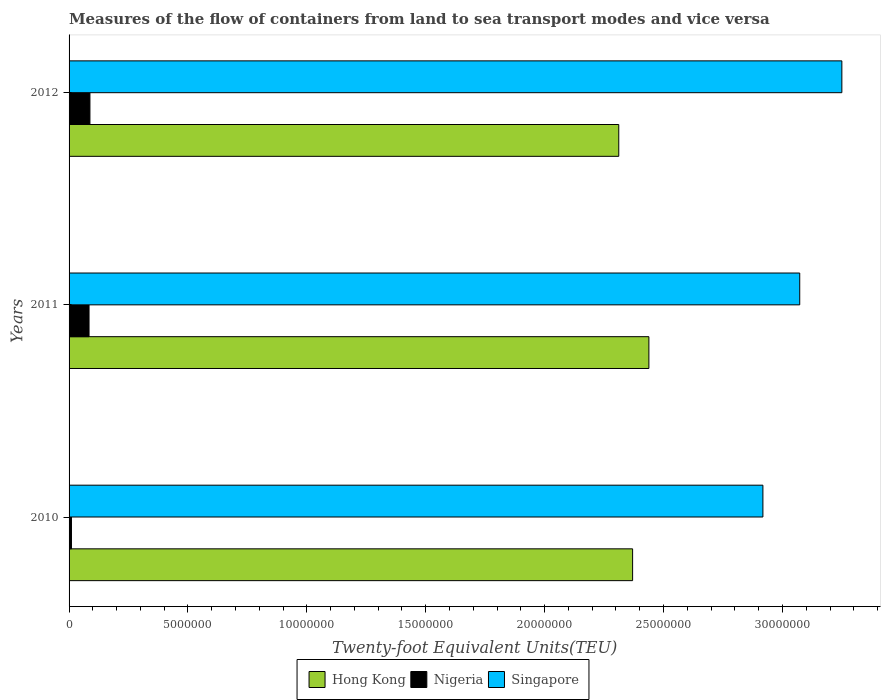How many different coloured bars are there?
Provide a succinct answer. 3. How many bars are there on the 1st tick from the top?
Provide a succinct answer. 3. How many bars are there on the 3rd tick from the bottom?
Offer a very short reply. 3. In how many cases, is the number of bars for a given year not equal to the number of legend labels?
Give a very brief answer. 0. What is the container port traffic in Nigeria in 2010?
Offer a terse response. 1.01e+05. Across all years, what is the maximum container port traffic in Hong Kong?
Keep it short and to the point. 2.44e+07. Across all years, what is the minimum container port traffic in Singapore?
Your answer should be compact. 2.92e+07. In which year was the container port traffic in Singapore maximum?
Give a very brief answer. 2012. What is the total container port traffic in Hong Kong in the graph?
Offer a terse response. 7.12e+07. What is the difference between the container port traffic in Nigeria in 2011 and that in 2012?
Give a very brief answer. -3.78e+04. What is the difference between the container port traffic in Hong Kong in 2011 and the container port traffic in Singapore in 2012?
Your response must be concise. -8.11e+06. What is the average container port traffic in Singapore per year?
Give a very brief answer. 3.08e+07. In the year 2012, what is the difference between the container port traffic in Nigeria and container port traffic in Singapore?
Your response must be concise. -3.16e+07. In how many years, is the container port traffic in Singapore greater than 18000000 TEU?
Give a very brief answer. 3. What is the ratio of the container port traffic in Hong Kong in 2010 to that in 2011?
Keep it short and to the point. 0.97. Is the difference between the container port traffic in Nigeria in 2010 and 2011 greater than the difference between the container port traffic in Singapore in 2010 and 2011?
Make the answer very short. Yes. What is the difference between the highest and the second highest container port traffic in Hong Kong?
Keep it short and to the point. 6.85e+05. What is the difference between the highest and the lowest container port traffic in Nigeria?
Your response must be concise. 7.77e+05. Is the sum of the container port traffic in Singapore in 2010 and 2012 greater than the maximum container port traffic in Hong Kong across all years?
Make the answer very short. Yes. What does the 1st bar from the top in 2011 represents?
Your answer should be very brief. Singapore. What does the 2nd bar from the bottom in 2010 represents?
Make the answer very short. Nigeria. Is it the case that in every year, the sum of the container port traffic in Hong Kong and container port traffic in Singapore is greater than the container port traffic in Nigeria?
Your response must be concise. Yes. What is the difference between two consecutive major ticks on the X-axis?
Keep it short and to the point. 5.00e+06. Are the values on the major ticks of X-axis written in scientific E-notation?
Keep it short and to the point. No. Does the graph contain any zero values?
Your answer should be very brief. No. Does the graph contain grids?
Ensure brevity in your answer.  No. Where does the legend appear in the graph?
Provide a succinct answer. Bottom center. What is the title of the graph?
Your answer should be compact. Measures of the flow of containers from land to sea transport modes and vice versa. What is the label or title of the X-axis?
Offer a terse response. Twenty-foot Equivalent Units(TEU). What is the label or title of the Y-axis?
Your response must be concise. Years. What is the Twenty-foot Equivalent Units(TEU) in Hong Kong in 2010?
Make the answer very short. 2.37e+07. What is the Twenty-foot Equivalent Units(TEU) in Nigeria in 2010?
Your answer should be compact. 1.01e+05. What is the Twenty-foot Equivalent Units(TEU) of Singapore in 2010?
Give a very brief answer. 2.92e+07. What is the Twenty-foot Equivalent Units(TEU) in Hong Kong in 2011?
Offer a very short reply. 2.44e+07. What is the Twenty-foot Equivalent Units(TEU) of Nigeria in 2011?
Your answer should be very brief. 8.40e+05. What is the Twenty-foot Equivalent Units(TEU) in Singapore in 2011?
Offer a terse response. 3.07e+07. What is the Twenty-foot Equivalent Units(TEU) of Hong Kong in 2012?
Keep it short and to the point. 2.31e+07. What is the Twenty-foot Equivalent Units(TEU) in Nigeria in 2012?
Offer a very short reply. 8.78e+05. What is the Twenty-foot Equivalent Units(TEU) of Singapore in 2012?
Make the answer very short. 3.25e+07. Across all years, what is the maximum Twenty-foot Equivalent Units(TEU) of Hong Kong?
Make the answer very short. 2.44e+07. Across all years, what is the maximum Twenty-foot Equivalent Units(TEU) of Nigeria?
Your answer should be compact. 8.78e+05. Across all years, what is the maximum Twenty-foot Equivalent Units(TEU) of Singapore?
Your answer should be very brief. 3.25e+07. Across all years, what is the minimum Twenty-foot Equivalent Units(TEU) of Hong Kong?
Make the answer very short. 2.31e+07. Across all years, what is the minimum Twenty-foot Equivalent Units(TEU) in Nigeria?
Ensure brevity in your answer.  1.01e+05. Across all years, what is the minimum Twenty-foot Equivalent Units(TEU) in Singapore?
Keep it short and to the point. 2.92e+07. What is the total Twenty-foot Equivalent Units(TEU) of Hong Kong in the graph?
Your response must be concise. 7.12e+07. What is the total Twenty-foot Equivalent Units(TEU) of Nigeria in the graph?
Your response must be concise. 1.82e+06. What is the total Twenty-foot Equivalent Units(TEU) of Singapore in the graph?
Provide a succinct answer. 9.24e+07. What is the difference between the Twenty-foot Equivalent Units(TEU) in Hong Kong in 2010 and that in 2011?
Offer a very short reply. -6.85e+05. What is the difference between the Twenty-foot Equivalent Units(TEU) in Nigeria in 2010 and that in 2011?
Make the answer very short. -7.39e+05. What is the difference between the Twenty-foot Equivalent Units(TEU) of Singapore in 2010 and that in 2011?
Provide a succinct answer. -1.55e+06. What is the difference between the Twenty-foot Equivalent Units(TEU) in Hong Kong in 2010 and that in 2012?
Your answer should be compact. 5.82e+05. What is the difference between the Twenty-foot Equivalent Units(TEU) of Nigeria in 2010 and that in 2012?
Keep it short and to the point. -7.77e+05. What is the difference between the Twenty-foot Equivalent Units(TEU) in Singapore in 2010 and that in 2012?
Make the answer very short. -3.32e+06. What is the difference between the Twenty-foot Equivalent Units(TEU) in Hong Kong in 2011 and that in 2012?
Your answer should be compact. 1.27e+06. What is the difference between the Twenty-foot Equivalent Units(TEU) in Nigeria in 2011 and that in 2012?
Your answer should be very brief. -3.78e+04. What is the difference between the Twenty-foot Equivalent Units(TEU) in Singapore in 2011 and that in 2012?
Keep it short and to the point. -1.77e+06. What is the difference between the Twenty-foot Equivalent Units(TEU) in Hong Kong in 2010 and the Twenty-foot Equivalent Units(TEU) in Nigeria in 2011?
Keep it short and to the point. 2.29e+07. What is the difference between the Twenty-foot Equivalent Units(TEU) in Hong Kong in 2010 and the Twenty-foot Equivalent Units(TEU) in Singapore in 2011?
Your response must be concise. -7.03e+06. What is the difference between the Twenty-foot Equivalent Units(TEU) of Nigeria in 2010 and the Twenty-foot Equivalent Units(TEU) of Singapore in 2011?
Your answer should be compact. -3.06e+07. What is the difference between the Twenty-foot Equivalent Units(TEU) in Hong Kong in 2010 and the Twenty-foot Equivalent Units(TEU) in Nigeria in 2012?
Your response must be concise. 2.28e+07. What is the difference between the Twenty-foot Equivalent Units(TEU) in Hong Kong in 2010 and the Twenty-foot Equivalent Units(TEU) in Singapore in 2012?
Your answer should be compact. -8.80e+06. What is the difference between the Twenty-foot Equivalent Units(TEU) of Nigeria in 2010 and the Twenty-foot Equivalent Units(TEU) of Singapore in 2012?
Ensure brevity in your answer.  -3.24e+07. What is the difference between the Twenty-foot Equivalent Units(TEU) of Hong Kong in 2011 and the Twenty-foot Equivalent Units(TEU) of Nigeria in 2012?
Offer a very short reply. 2.35e+07. What is the difference between the Twenty-foot Equivalent Units(TEU) of Hong Kong in 2011 and the Twenty-foot Equivalent Units(TEU) of Singapore in 2012?
Provide a short and direct response. -8.11e+06. What is the difference between the Twenty-foot Equivalent Units(TEU) of Nigeria in 2011 and the Twenty-foot Equivalent Units(TEU) of Singapore in 2012?
Your answer should be compact. -3.17e+07. What is the average Twenty-foot Equivalent Units(TEU) in Hong Kong per year?
Provide a short and direct response. 2.37e+07. What is the average Twenty-foot Equivalent Units(TEU) of Nigeria per year?
Your response must be concise. 6.06e+05. What is the average Twenty-foot Equivalent Units(TEU) in Singapore per year?
Give a very brief answer. 3.08e+07. In the year 2010, what is the difference between the Twenty-foot Equivalent Units(TEU) in Hong Kong and Twenty-foot Equivalent Units(TEU) in Nigeria?
Provide a succinct answer. 2.36e+07. In the year 2010, what is the difference between the Twenty-foot Equivalent Units(TEU) in Hong Kong and Twenty-foot Equivalent Units(TEU) in Singapore?
Provide a succinct answer. -5.48e+06. In the year 2010, what is the difference between the Twenty-foot Equivalent Units(TEU) in Nigeria and Twenty-foot Equivalent Units(TEU) in Singapore?
Your answer should be compact. -2.91e+07. In the year 2011, what is the difference between the Twenty-foot Equivalent Units(TEU) of Hong Kong and Twenty-foot Equivalent Units(TEU) of Nigeria?
Your response must be concise. 2.35e+07. In the year 2011, what is the difference between the Twenty-foot Equivalent Units(TEU) of Hong Kong and Twenty-foot Equivalent Units(TEU) of Singapore?
Keep it short and to the point. -6.34e+06. In the year 2011, what is the difference between the Twenty-foot Equivalent Units(TEU) in Nigeria and Twenty-foot Equivalent Units(TEU) in Singapore?
Ensure brevity in your answer.  -2.99e+07. In the year 2012, what is the difference between the Twenty-foot Equivalent Units(TEU) of Hong Kong and Twenty-foot Equivalent Units(TEU) of Nigeria?
Your response must be concise. 2.22e+07. In the year 2012, what is the difference between the Twenty-foot Equivalent Units(TEU) of Hong Kong and Twenty-foot Equivalent Units(TEU) of Singapore?
Provide a short and direct response. -9.38e+06. In the year 2012, what is the difference between the Twenty-foot Equivalent Units(TEU) of Nigeria and Twenty-foot Equivalent Units(TEU) of Singapore?
Offer a very short reply. -3.16e+07. What is the ratio of the Twenty-foot Equivalent Units(TEU) in Hong Kong in 2010 to that in 2011?
Provide a short and direct response. 0.97. What is the ratio of the Twenty-foot Equivalent Units(TEU) of Nigeria in 2010 to that in 2011?
Give a very brief answer. 0.12. What is the ratio of the Twenty-foot Equivalent Units(TEU) of Singapore in 2010 to that in 2011?
Offer a terse response. 0.95. What is the ratio of the Twenty-foot Equivalent Units(TEU) in Hong Kong in 2010 to that in 2012?
Your response must be concise. 1.03. What is the ratio of the Twenty-foot Equivalent Units(TEU) in Nigeria in 2010 to that in 2012?
Offer a terse response. 0.12. What is the ratio of the Twenty-foot Equivalent Units(TEU) in Singapore in 2010 to that in 2012?
Provide a short and direct response. 0.9. What is the ratio of the Twenty-foot Equivalent Units(TEU) of Hong Kong in 2011 to that in 2012?
Offer a terse response. 1.05. What is the ratio of the Twenty-foot Equivalent Units(TEU) in Singapore in 2011 to that in 2012?
Keep it short and to the point. 0.95. What is the difference between the highest and the second highest Twenty-foot Equivalent Units(TEU) in Hong Kong?
Keep it short and to the point. 6.85e+05. What is the difference between the highest and the second highest Twenty-foot Equivalent Units(TEU) of Nigeria?
Ensure brevity in your answer.  3.78e+04. What is the difference between the highest and the second highest Twenty-foot Equivalent Units(TEU) in Singapore?
Your response must be concise. 1.77e+06. What is the difference between the highest and the lowest Twenty-foot Equivalent Units(TEU) in Hong Kong?
Keep it short and to the point. 1.27e+06. What is the difference between the highest and the lowest Twenty-foot Equivalent Units(TEU) of Nigeria?
Offer a very short reply. 7.77e+05. What is the difference between the highest and the lowest Twenty-foot Equivalent Units(TEU) in Singapore?
Provide a short and direct response. 3.32e+06. 